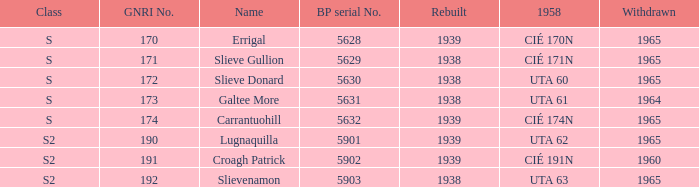What is the minimum withdrawn value of a gnri greater than 172, called croagh patrick, and reconstructed prior to 1939? None. 